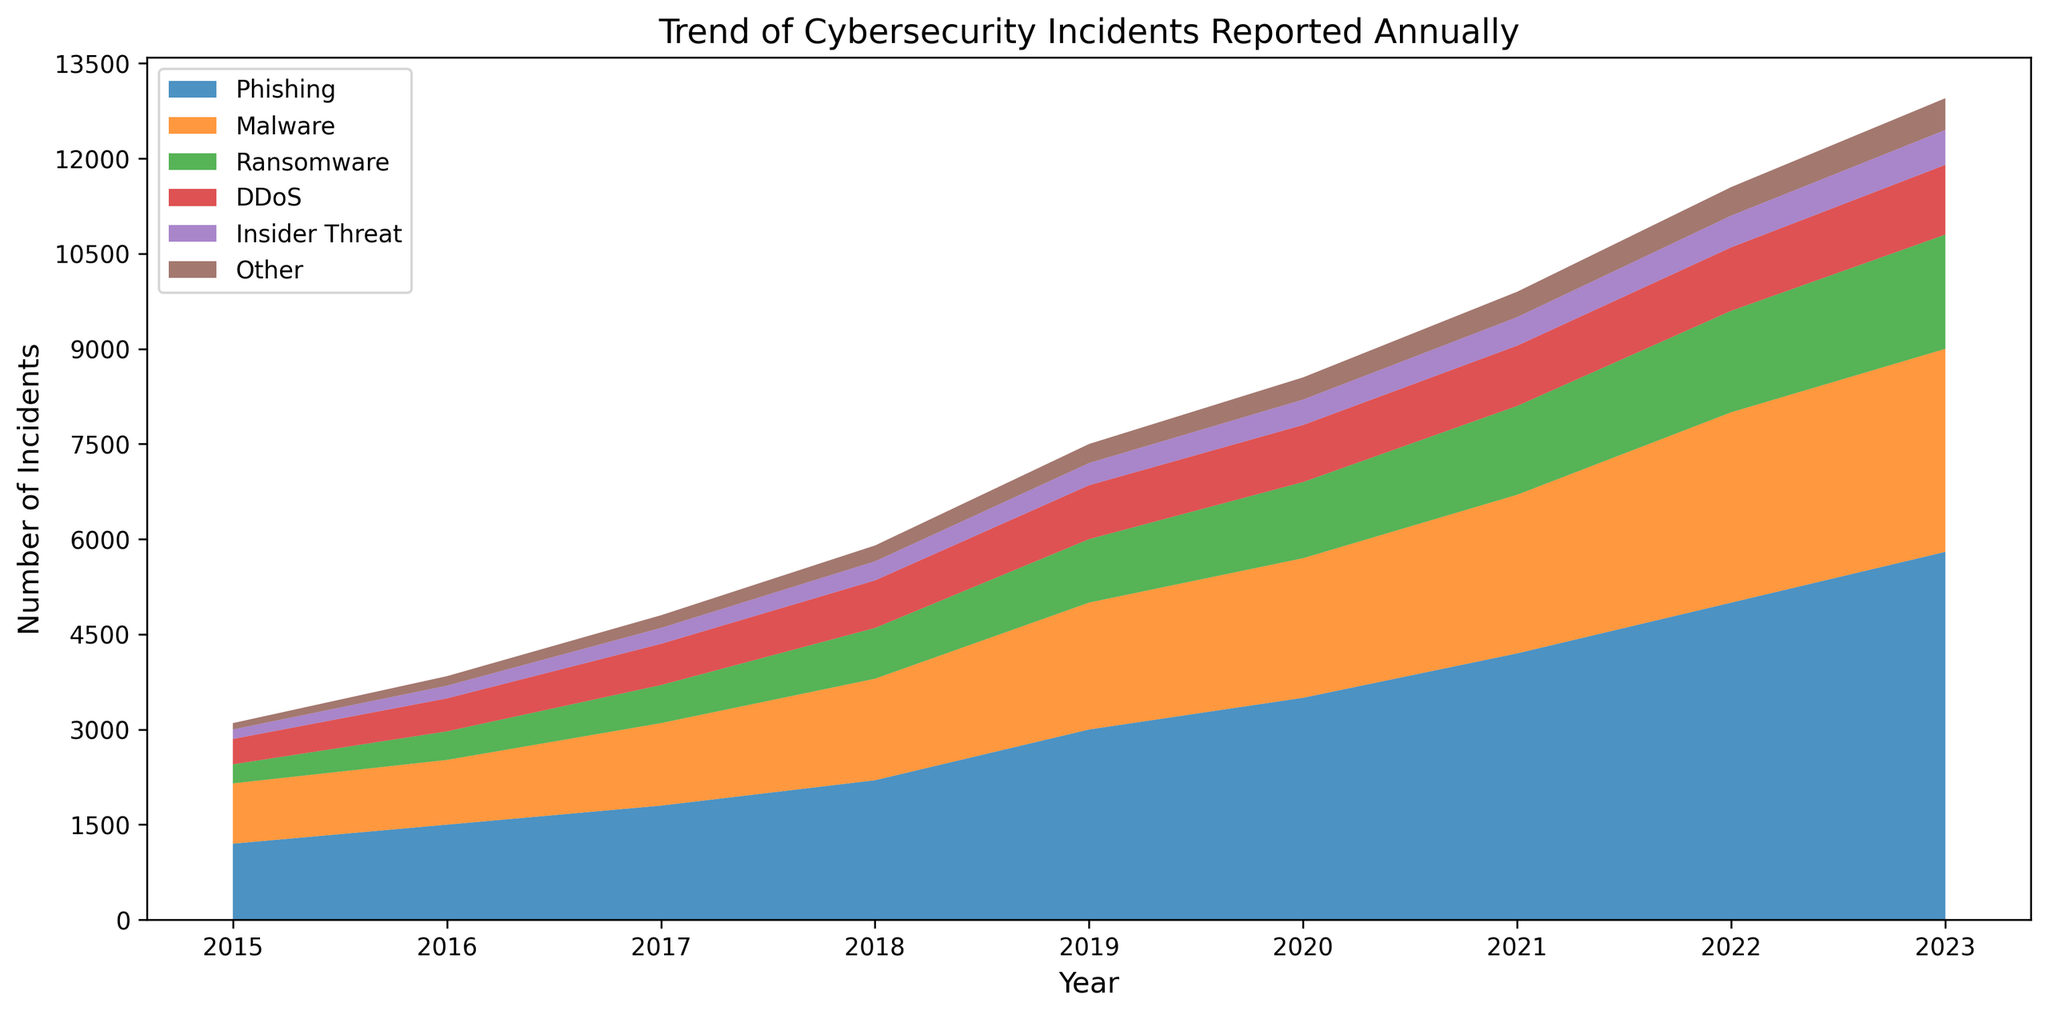What is the total number of incidents reported in 2022? First, find the value for each category in 2022: Phishing (5000), Malware (3000), Ransomware (1600), DDoS (1000), Insider Threat (500), Other (450). Summing these values gives 5000 + 3000 + 1600 + 1000 + 500 + 450 = 11550.
Answer: 11550 Which type of attack showed the largest increase from 2015 to 2023? Compare the values for each category between 2015 and 2023. Phishing increased from 1200 to 5800 (4600 increase), Malware from 950 to 3200 (2250 increase), Ransomware from 300 to 1800 (1500 increase), DDoS from 400 to 1100 (700 increase), Insider Threat from 150 to 550 (400 increase), and Other from 100 to 500 (400 increase). The largest increase is for Phishing.
Answer: Phishing How did the number of Ransomware incidents change from 2015 to 2017? In 2015, there were 300 Ransomware incidents, and in 2017, there were 600. Subtract the 2015 value from the 2017 value: 600 - 300 = 300. The change is an increase of 300.
Answer: Increased by 300 Which two years had the most similar total number of cybersecurity incidents reported? Calculate the total number of incidents for each year. Compare the totals to find the two closest ones. 2018 (5900) and 2020 (7650) are the two years with the most similar total numbers: 7650 - 5900 = 1750.
Answer: 2018 and 2020 What was the percentage increase in Phishing incidents from 2019 to 2022? In 2019, there were 3000 Phishing incidents, and in 2022, there were 5000. Calculate the percentage increase: (5000 - 3000) / 3000 * 100 = 66.67%.
Answer: 66.67% Which category has consistently increased every year? Examine the trends for each category. Phishing, Malware, Ransomware, and DDoS all show a consistent yearly increase, but the category with the most consistent and significant increase every year is Phishing.
Answer: Phishing What is the combined difference in the number of Malware and DDoS incidents between 2020 and 2021? In 2020, Malware incidents were 2200 and DDoS incidents were 900. In 2021, Malware incidents were 2500 and DDoS incidents were 950. Calculate the differences: Malware (2500 - 2200 = 300), DDoS (950 - 900 = 50). The combined difference is 300 + 50 = 350.
Answer: 350 Between what years did the number of Insider Threat incidents remain the same? Look for years where the number of Insider Threat incidents did not change. The data show that Insider Threat incidents were 400 in both 2020 and 2021.
Answer: 2020 and 2021 